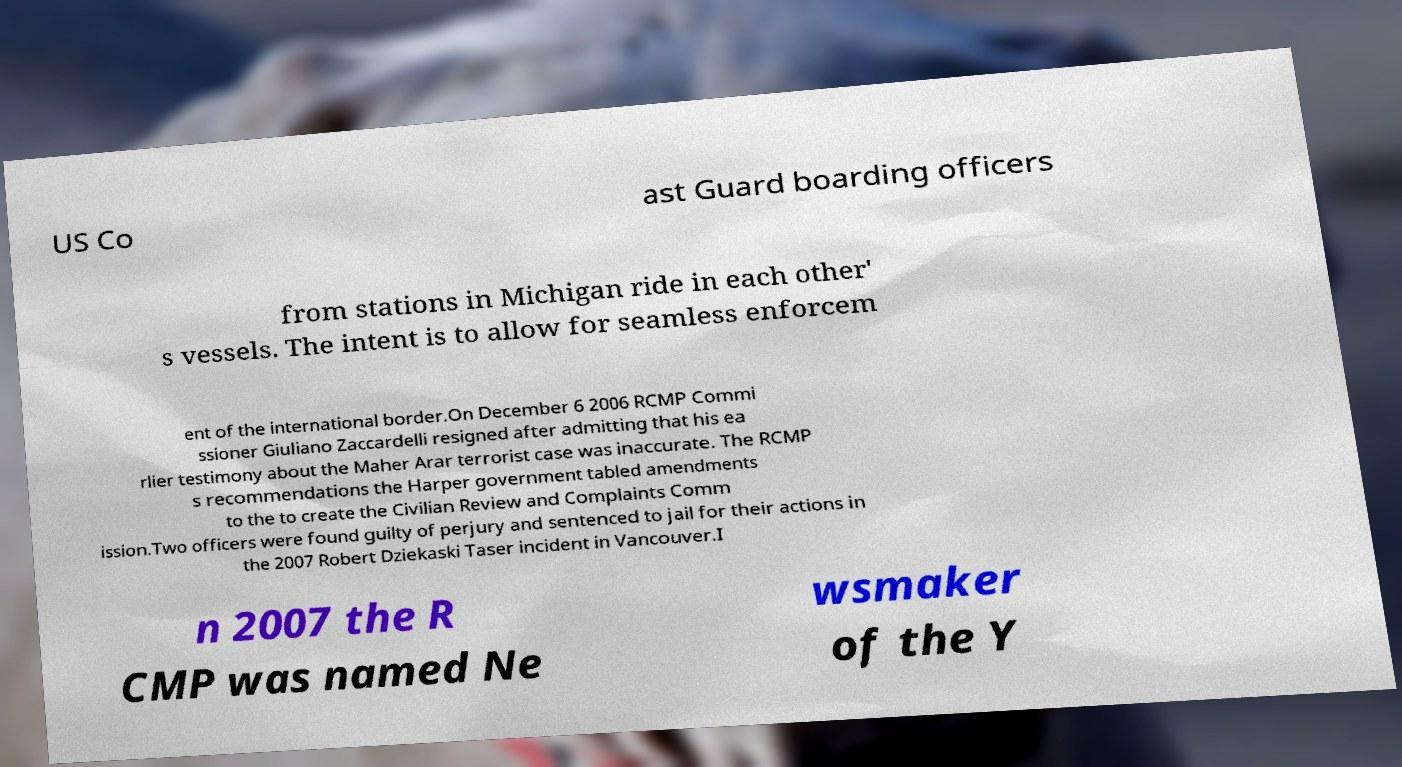Could you extract and type out the text from this image? US Co ast Guard boarding officers from stations in Michigan ride in each other' s vessels. The intent is to allow for seamless enforcem ent of the international border.On December 6 2006 RCMP Commi ssioner Giuliano Zaccardelli resigned after admitting that his ea rlier testimony about the Maher Arar terrorist case was inaccurate. The RCMP s recommendations the Harper government tabled amendments to the to create the Civilian Review and Complaints Comm ission.Two officers were found guilty of perjury and sentenced to jail for their actions in the 2007 Robert Dziekaski Taser incident in Vancouver.I n 2007 the R CMP was named Ne wsmaker of the Y 